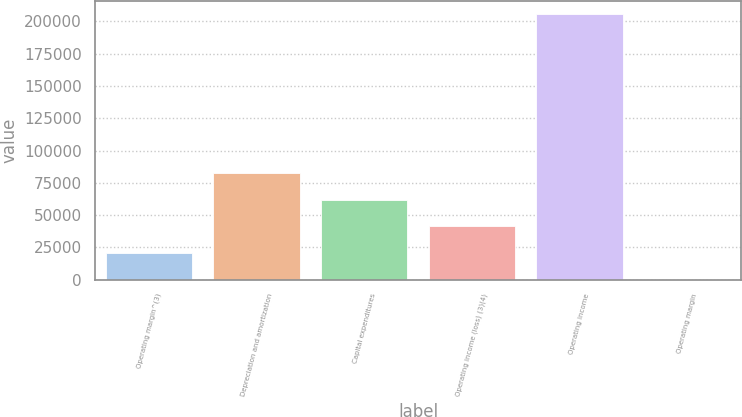<chart> <loc_0><loc_0><loc_500><loc_500><bar_chart><fcel>Operating margin^(3)<fcel>Depreciation and amortization<fcel>Capital expenditures<fcel>Operating income (loss) (3)(4)<fcel>Operating income<fcel>Operating margin<nl><fcel>20608<fcel>82390.7<fcel>61796.5<fcel>41202.2<fcel>205956<fcel>13.8<nl></chart> 